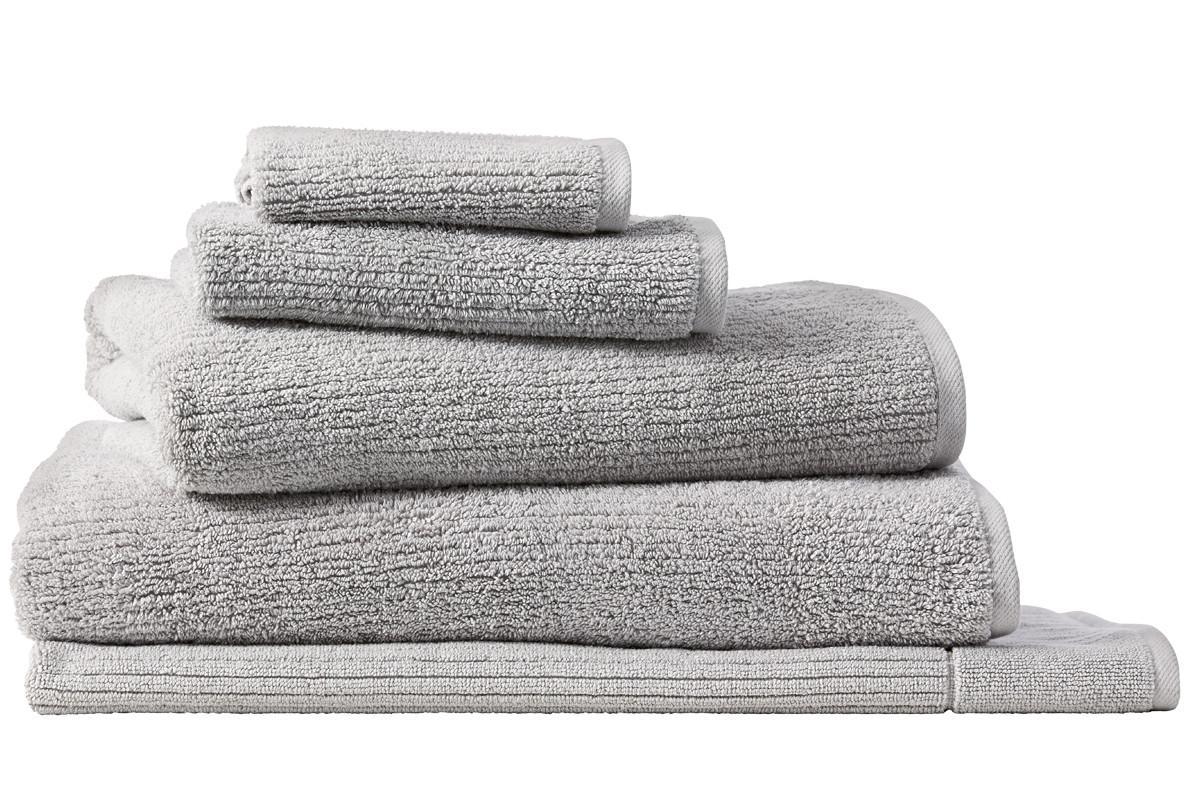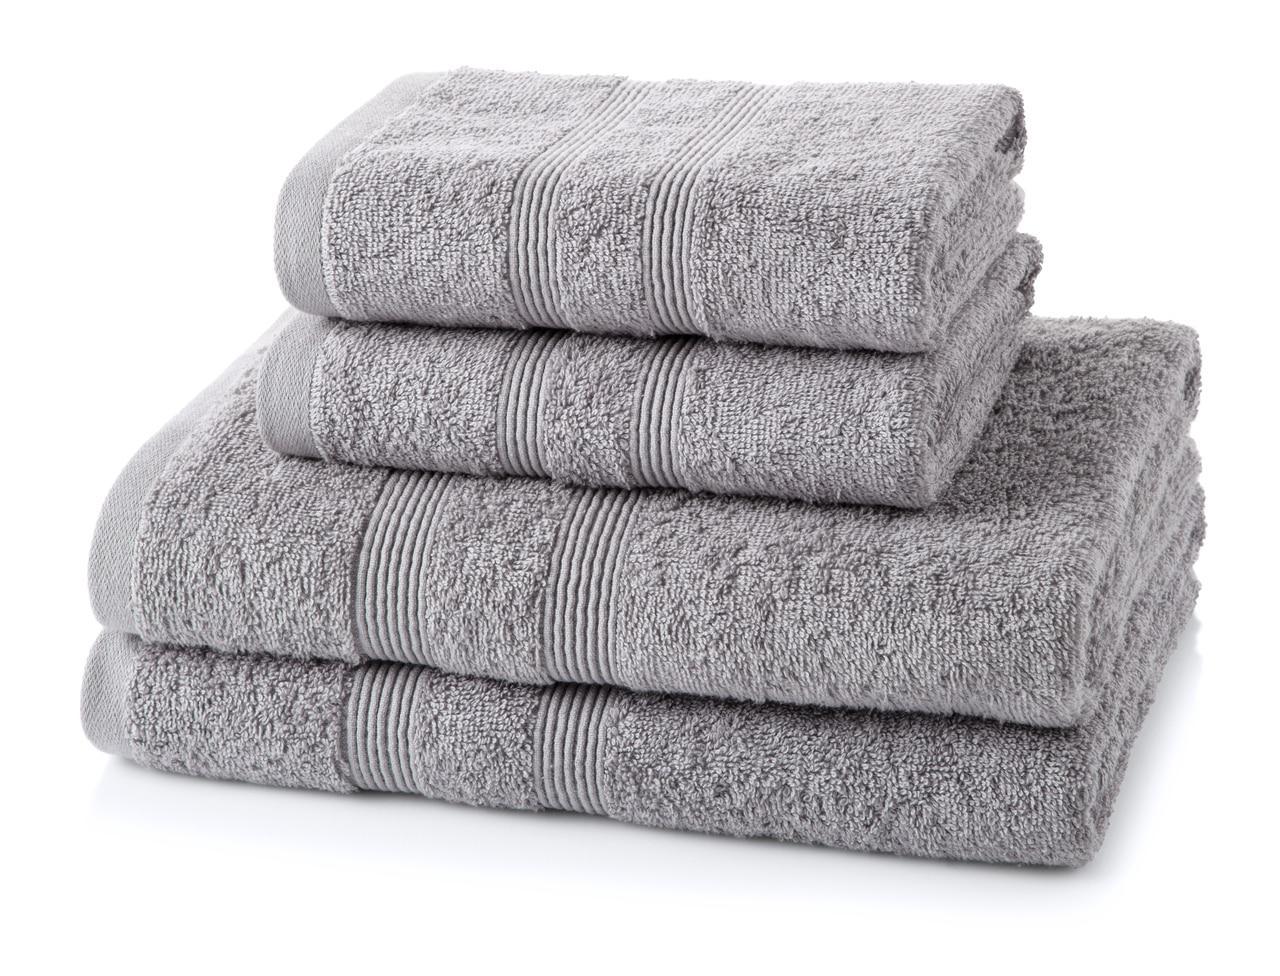The first image is the image on the left, the second image is the image on the right. Considering the images on both sides, is "The left and right image contains a total of nine towels." valid? Answer yes or no. Yes. The first image is the image on the left, the second image is the image on the right. Assess this claim about the two images: "There are more items in the left image than in the right image.". Correct or not? Answer yes or no. Yes. 